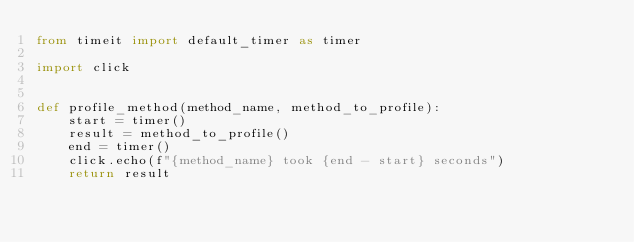Convert code to text. <code><loc_0><loc_0><loc_500><loc_500><_Python_>from timeit import default_timer as timer

import click


def profile_method(method_name, method_to_profile):
    start = timer()
    result = method_to_profile()
    end = timer()
    click.echo(f"{method_name} took {end - start} seconds")
    return result
</code> 